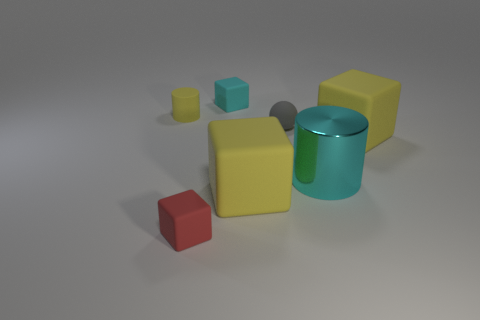Is there any other thing that has the same material as the large cylinder?
Give a very brief answer. No. Is there anything else that is the same shape as the red thing?
Offer a terse response. Yes. Is the material of the tiny cyan cube the same as the tiny cube in front of the small cylinder?
Make the answer very short. Yes. The small block behind the red cube that is left of the cyan object on the left side of the big cyan shiny cylinder is what color?
Your answer should be compact. Cyan. There is a red rubber object that is the same size as the rubber sphere; what shape is it?
Provide a short and direct response. Cube. Are there any other things that are the same size as the gray object?
Give a very brief answer. Yes. Do the yellow matte thing left of the tiny red object and the yellow rubber block that is on the right side of the tiny gray ball have the same size?
Offer a very short reply. No. There is a cylinder to the left of the metal cylinder; what is its size?
Your answer should be compact. Small. There is a tiny cube that is the same color as the large metal thing; what material is it?
Make the answer very short. Rubber. The matte cylinder that is the same size as the cyan matte thing is what color?
Offer a very short reply. Yellow. 